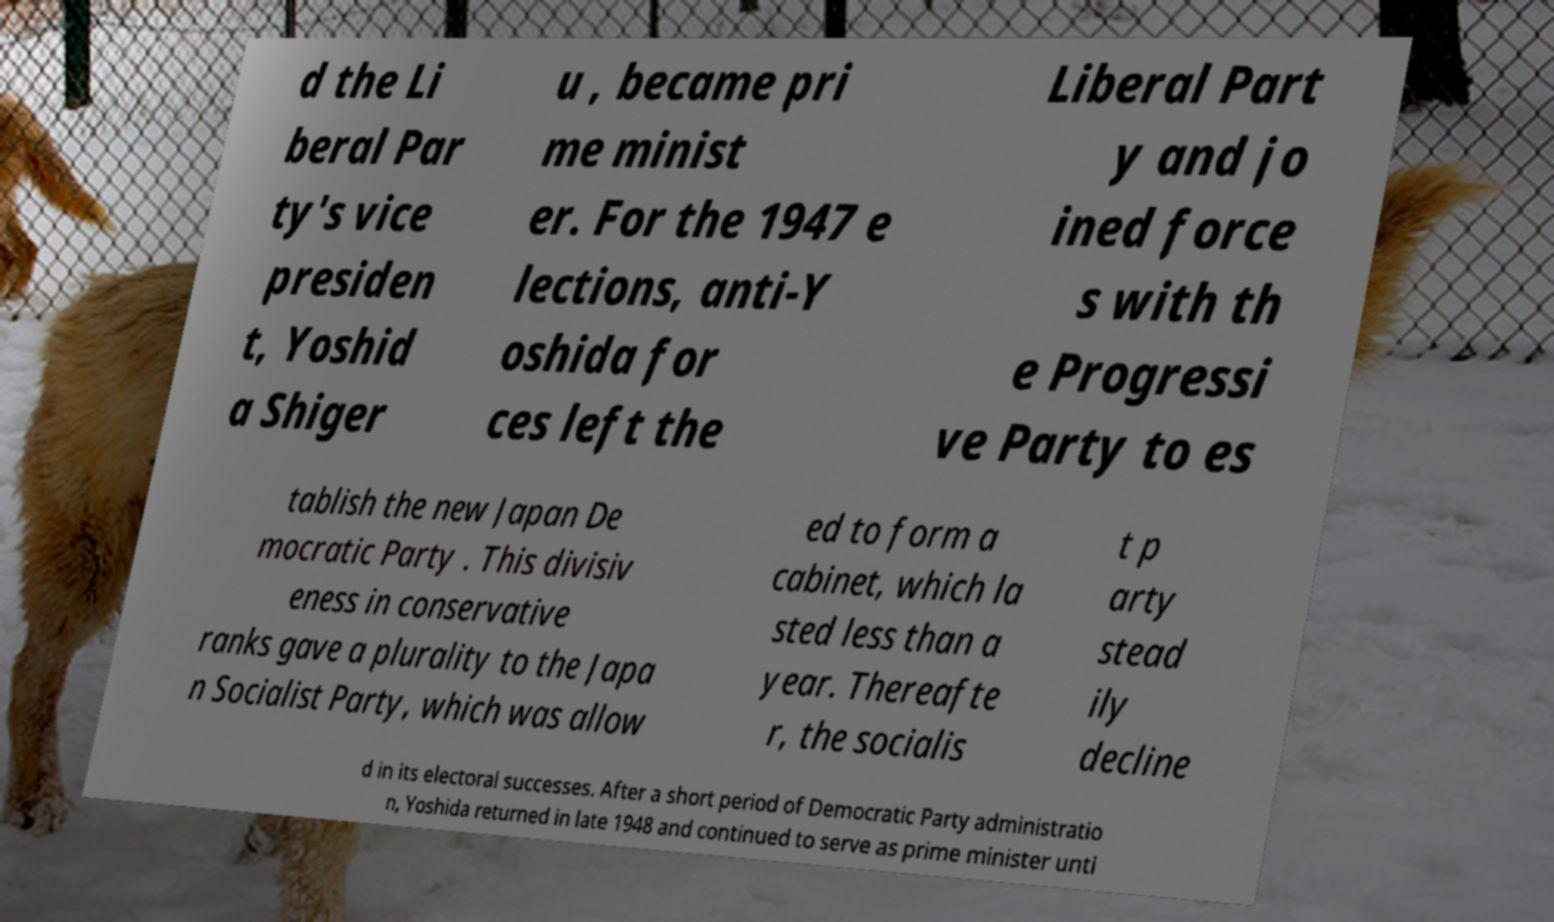Please identify and transcribe the text found in this image. d the Li beral Par ty's vice presiden t, Yoshid a Shiger u , became pri me minist er. For the 1947 e lections, anti-Y oshida for ces left the Liberal Part y and jo ined force s with th e Progressi ve Party to es tablish the new Japan De mocratic Party . This divisiv eness in conservative ranks gave a plurality to the Japa n Socialist Party, which was allow ed to form a cabinet, which la sted less than a year. Thereafte r, the socialis t p arty stead ily decline d in its electoral successes. After a short period of Democratic Party administratio n, Yoshida returned in late 1948 and continued to serve as prime minister unti 